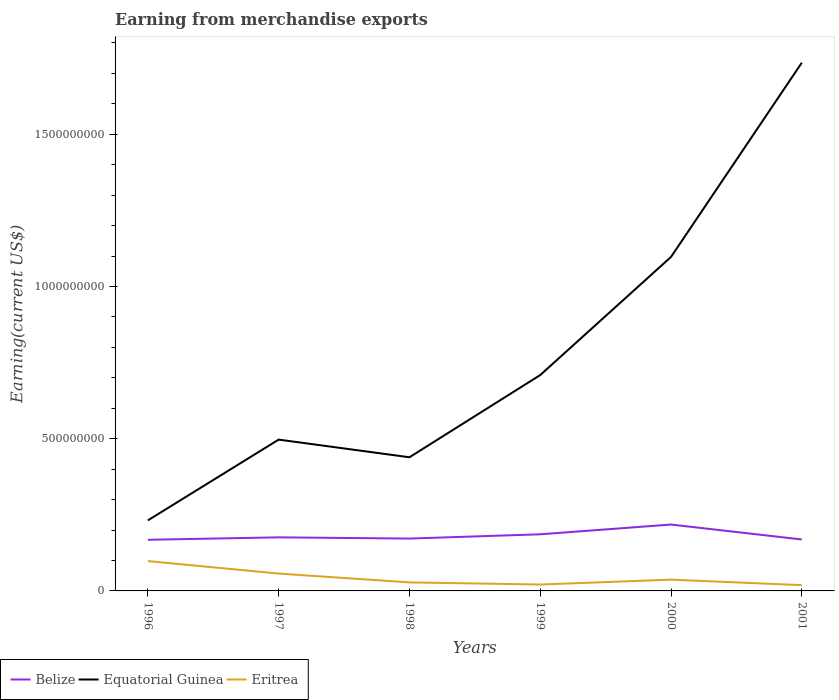How many different coloured lines are there?
Provide a short and direct response. 3. Is the number of lines equal to the number of legend labels?
Keep it short and to the point. Yes. Across all years, what is the maximum amount earned from merchandise exports in Eritrea?
Keep it short and to the point. 1.90e+07. In which year was the amount earned from merchandise exports in Equatorial Guinea maximum?
Offer a very short reply. 1996. What is the total amount earned from merchandise exports in Eritrea in the graph?
Offer a terse response. 7.70e+07. What is the difference between the highest and the lowest amount earned from merchandise exports in Equatorial Guinea?
Ensure brevity in your answer.  2. Is the amount earned from merchandise exports in Eritrea strictly greater than the amount earned from merchandise exports in Belize over the years?
Your answer should be compact. Yes. How many lines are there?
Your answer should be very brief. 3. Does the graph contain any zero values?
Make the answer very short. No. Does the graph contain grids?
Your answer should be very brief. No. Where does the legend appear in the graph?
Your response must be concise. Bottom left. How many legend labels are there?
Your answer should be compact. 3. What is the title of the graph?
Your answer should be very brief. Earning from merchandise exports. Does "Malawi" appear as one of the legend labels in the graph?
Provide a short and direct response. No. What is the label or title of the X-axis?
Give a very brief answer. Years. What is the label or title of the Y-axis?
Offer a very short reply. Earning(current US$). What is the Earning(current US$) of Belize in 1996?
Your answer should be very brief. 1.68e+08. What is the Earning(current US$) in Equatorial Guinea in 1996?
Ensure brevity in your answer.  2.32e+08. What is the Earning(current US$) of Eritrea in 1996?
Make the answer very short. 9.80e+07. What is the Earning(current US$) of Belize in 1997?
Your response must be concise. 1.76e+08. What is the Earning(current US$) of Equatorial Guinea in 1997?
Your response must be concise. 4.97e+08. What is the Earning(current US$) of Eritrea in 1997?
Give a very brief answer. 5.70e+07. What is the Earning(current US$) in Belize in 1998?
Your answer should be compact. 1.72e+08. What is the Earning(current US$) in Equatorial Guinea in 1998?
Offer a terse response. 4.39e+08. What is the Earning(current US$) of Eritrea in 1998?
Offer a very short reply. 2.80e+07. What is the Earning(current US$) in Belize in 1999?
Keep it short and to the point. 1.86e+08. What is the Earning(current US$) of Equatorial Guinea in 1999?
Give a very brief answer. 7.09e+08. What is the Earning(current US$) of Eritrea in 1999?
Offer a very short reply. 2.10e+07. What is the Earning(current US$) in Belize in 2000?
Provide a short and direct response. 2.18e+08. What is the Earning(current US$) in Equatorial Guinea in 2000?
Provide a succinct answer. 1.10e+09. What is the Earning(current US$) of Eritrea in 2000?
Make the answer very short. 3.70e+07. What is the Earning(current US$) of Belize in 2001?
Your response must be concise. 1.69e+08. What is the Earning(current US$) in Equatorial Guinea in 2001?
Offer a terse response. 1.74e+09. What is the Earning(current US$) of Eritrea in 2001?
Provide a short and direct response. 1.90e+07. Across all years, what is the maximum Earning(current US$) in Belize?
Your response must be concise. 2.18e+08. Across all years, what is the maximum Earning(current US$) in Equatorial Guinea?
Provide a short and direct response. 1.74e+09. Across all years, what is the maximum Earning(current US$) of Eritrea?
Your response must be concise. 9.80e+07. Across all years, what is the minimum Earning(current US$) of Belize?
Offer a terse response. 1.68e+08. Across all years, what is the minimum Earning(current US$) of Equatorial Guinea?
Give a very brief answer. 2.32e+08. Across all years, what is the minimum Earning(current US$) of Eritrea?
Make the answer very short. 1.90e+07. What is the total Earning(current US$) in Belize in the graph?
Your answer should be compact. 1.09e+09. What is the total Earning(current US$) in Equatorial Guinea in the graph?
Give a very brief answer. 4.71e+09. What is the total Earning(current US$) of Eritrea in the graph?
Provide a short and direct response. 2.60e+08. What is the difference between the Earning(current US$) in Belize in 1996 and that in 1997?
Your answer should be very brief. -8.00e+06. What is the difference between the Earning(current US$) of Equatorial Guinea in 1996 and that in 1997?
Make the answer very short. -2.65e+08. What is the difference between the Earning(current US$) of Eritrea in 1996 and that in 1997?
Provide a short and direct response. 4.10e+07. What is the difference between the Earning(current US$) of Belize in 1996 and that in 1998?
Ensure brevity in your answer.  -4.00e+06. What is the difference between the Earning(current US$) in Equatorial Guinea in 1996 and that in 1998?
Your response must be concise. -2.07e+08. What is the difference between the Earning(current US$) of Eritrea in 1996 and that in 1998?
Your response must be concise. 7.00e+07. What is the difference between the Earning(current US$) in Belize in 1996 and that in 1999?
Your response must be concise. -1.80e+07. What is the difference between the Earning(current US$) of Equatorial Guinea in 1996 and that in 1999?
Keep it short and to the point. -4.77e+08. What is the difference between the Earning(current US$) in Eritrea in 1996 and that in 1999?
Your answer should be compact. 7.70e+07. What is the difference between the Earning(current US$) in Belize in 1996 and that in 2000?
Offer a terse response. -5.00e+07. What is the difference between the Earning(current US$) in Equatorial Guinea in 1996 and that in 2000?
Keep it short and to the point. -8.65e+08. What is the difference between the Earning(current US$) in Eritrea in 1996 and that in 2000?
Ensure brevity in your answer.  6.10e+07. What is the difference between the Earning(current US$) in Belize in 1996 and that in 2001?
Your answer should be compact. -1.00e+06. What is the difference between the Earning(current US$) of Equatorial Guinea in 1996 and that in 2001?
Make the answer very short. -1.50e+09. What is the difference between the Earning(current US$) in Eritrea in 1996 and that in 2001?
Provide a succinct answer. 7.90e+07. What is the difference between the Earning(current US$) of Belize in 1997 and that in 1998?
Ensure brevity in your answer.  4.00e+06. What is the difference between the Earning(current US$) of Equatorial Guinea in 1997 and that in 1998?
Offer a very short reply. 5.80e+07. What is the difference between the Earning(current US$) in Eritrea in 1997 and that in 1998?
Keep it short and to the point. 2.90e+07. What is the difference between the Earning(current US$) in Belize in 1997 and that in 1999?
Give a very brief answer. -1.00e+07. What is the difference between the Earning(current US$) in Equatorial Guinea in 1997 and that in 1999?
Keep it short and to the point. -2.12e+08. What is the difference between the Earning(current US$) of Eritrea in 1997 and that in 1999?
Offer a terse response. 3.60e+07. What is the difference between the Earning(current US$) of Belize in 1997 and that in 2000?
Make the answer very short. -4.20e+07. What is the difference between the Earning(current US$) in Equatorial Guinea in 1997 and that in 2000?
Ensure brevity in your answer.  -6.00e+08. What is the difference between the Earning(current US$) in Eritrea in 1997 and that in 2000?
Ensure brevity in your answer.  2.00e+07. What is the difference between the Earning(current US$) in Equatorial Guinea in 1997 and that in 2001?
Keep it short and to the point. -1.24e+09. What is the difference between the Earning(current US$) of Eritrea in 1997 and that in 2001?
Your answer should be very brief. 3.80e+07. What is the difference between the Earning(current US$) in Belize in 1998 and that in 1999?
Offer a terse response. -1.40e+07. What is the difference between the Earning(current US$) of Equatorial Guinea in 1998 and that in 1999?
Provide a short and direct response. -2.70e+08. What is the difference between the Earning(current US$) of Belize in 1998 and that in 2000?
Provide a short and direct response. -4.60e+07. What is the difference between the Earning(current US$) of Equatorial Guinea in 1998 and that in 2000?
Provide a succinct answer. -6.58e+08. What is the difference between the Earning(current US$) of Eritrea in 1998 and that in 2000?
Provide a succinct answer. -9.00e+06. What is the difference between the Earning(current US$) in Equatorial Guinea in 1998 and that in 2001?
Your response must be concise. -1.30e+09. What is the difference between the Earning(current US$) of Eritrea in 1998 and that in 2001?
Your answer should be very brief. 9.00e+06. What is the difference between the Earning(current US$) in Belize in 1999 and that in 2000?
Provide a short and direct response. -3.20e+07. What is the difference between the Earning(current US$) in Equatorial Guinea in 1999 and that in 2000?
Provide a succinct answer. -3.88e+08. What is the difference between the Earning(current US$) in Eritrea in 1999 and that in 2000?
Your response must be concise. -1.60e+07. What is the difference between the Earning(current US$) in Belize in 1999 and that in 2001?
Your answer should be compact. 1.70e+07. What is the difference between the Earning(current US$) of Equatorial Guinea in 1999 and that in 2001?
Make the answer very short. -1.03e+09. What is the difference between the Earning(current US$) of Eritrea in 1999 and that in 2001?
Your answer should be compact. 2.00e+06. What is the difference between the Earning(current US$) in Belize in 2000 and that in 2001?
Offer a terse response. 4.90e+07. What is the difference between the Earning(current US$) of Equatorial Guinea in 2000 and that in 2001?
Your answer should be very brief. -6.38e+08. What is the difference between the Earning(current US$) in Eritrea in 2000 and that in 2001?
Offer a terse response. 1.80e+07. What is the difference between the Earning(current US$) in Belize in 1996 and the Earning(current US$) in Equatorial Guinea in 1997?
Make the answer very short. -3.29e+08. What is the difference between the Earning(current US$) of Belize in 1996 and the Earning(current US$) of Eritrea in 1997?
Offer a very short reply. 1.11e+08. What is the difference between the Earning(current US$) in Equatorial Guinea in 1996 and the Earning(current US$) in Eritrea in 1997?
Ensure brevity in your answer.  1.75e+08. What is the difference between the Earning(current US$) in Belize in 1996 and the Earning(current US$) in Equatorial Guinea in 1998?
Provide a succinct answer. -2.71e+08. What is the difference between the Earning(current US$) in Belize in 1996 and the Earning(current US$) in Eritrea in 1998?
Give a very brief answer. 1.40e+08. What is the difference between the Earning(current US$) in Equatorial Guinea in 1996 and the Earning(current US$) in Eritrea in 1998?
Ensure brevity in your answer.  2.04e+08. What is the difference between the Earning(current US$) in Belize in 1996 and the Earning(current US$) in Equatorial Guinea in 1999?
Give a very brief answer. -5.41e+08. What is the difference between the Earning(current US$) of Belize in 1996 and the Earning(current US$) of Eritrea in 1999?
Ensure brevity in your answer.  1.47e+08. What is the difference between the Earning(current US$) in Equatorial Guinea in 1996 and the Earning(current US$) in Eritrea in 1999?
Provide a succinct answer. 2.11e+08. What is the difference between the Earning(current US$) in Belize in 1996 and the Earning(current US$) in Equatorial Guinea in 2000?
Offer a very short reply. -9.29e+08. What is the difference between the Earning(current US$) of Belize in 1996 and the Earning(current US$) of Eritrea in 2000?
Provide a succinct answer. 1.31e+08. What is the difference between the Earning(current US$) of Equatorial Guinea in 1996 and the Earning(current US$) of Eritrea in 2000?
Provide a succinct answer. 1.95e+08. What is the difference between the Earning(current US$) in Belize in 1996 and the Earning(current US$) in Equatorial Guinea in 2001?
Your answer should be compact. -1.57e+09. What is the difference between the Earning(current US$) in Belize in 1996 and the Earning(current US$) in Eritrea in 2001?
Your response must be concise. 1.49e+08. What is the difference between the Earning(current US$) of Equatorial Guinea in 1996 and the Earning(current US$) of Eritrea in 2001?
Ensure brevity in your answer.  2.13e+08. What is the difference between the Earning(current US$) in Belize in 1997 and the Earning(current US$) in Equatorial Guinea in 1998?
Your answer should be compact. -2.63e+08. What is the difference between the Earning(current US$) in Belize in 1997 and the Earning(current US$) in Eritrea in 1998?
Give a very brief answer. 1.48e+08. What is the difference between the Earning(current US$) of Equatorial Guinea in 1997 and the Earning(current US$) of Eritrea in 1998?
Offer a terse response. 4.69e+08. What is the difference between the Earning(current US$) in Belize in 1997 and the Earning(current US$) in Equatorial Guinea in 1999?
Make the answer very short. -5.33e+08. What is the difference between the Earning(current US$) of Belize in 1997 and the Earning(current US$) of Eritrea in 1999?
Give a very brief answer. 1.55e+08. What is the difference between the Earning(current US$) of Equatorial Guinea in 1997 and the Earning(current US$) of Eritrea in 1999?
Your answer should be compact. 4.76e+08. What is the difference between the Earning(current US$) in Belize in 1997 and the Earning(current US$) in Equatorial Guinea in 2000?
Make the answer very short. -9.21e+08. What is the difference between the Earning(current US$) in Belize in 1997 and the Earning(current US$) in Eritrea in 2000?
Make the answer very short. 1.39e+08. What is the difference between the Earning(current US$) in Equatorial Guinea in 1997 and the Earning(current US$) in Eritrea in 2000?
Keep it short and to the point. 4.60e+08. What is the difference between the Earning(current US$) of Belize in 1997 and the Earning(current US$) of Equatorial Guinea in 2001?
Provide a short and direct response. -1.56e+09. What is the difference between the Earning(current US$) in Belize in 1997 and the Earning(current US$) in Eritrea in 2001?
Your response must be concise. 1.57e+08. What is the difference between the Earning(current US$) in Equatorial Guinea in 1997 and the Earning(current US$) in Eritrea in 2001?
Give a very brief answer. 4.78e+08. What is the difference between the Earning(current US$) in Belize in 1998 and the Earning(current US$) in Equatorial Guinea in 1999?
Offer a terse response. -5.37e+08. What is the difference between the Earning(current US$) in Belize in 1998 and the Earning(current US$) in Eritrea in 1999?
Ensure brevity in your answer.  1.51e+08. What is the difference between the Earning(current US$) in Equatorial Guinea in 1998 and the Earning(current US$) in Eritrea in 1999?
Provide a short and direct response. 4.18e+08. What is the difference between the Earning(current US$) of Belize in 1998 and the Earning(current US$) of Equatorial Guinea in 2000?
Ensure brevity in your answer.  -9.25e+08. What is the difference between the Earning(current US$) in Belize in 1998 and the Earning(current US$) in Eritrea in 2000?
Give a very brief answer. 1.35e+08. What is the difference between the Earning(current US$) of Equatorial Guinea in 1998 and the Earning(current US$) of Eritrea in 2000?
Ensure brevity in your answer.  4.02e+08. What is the difference between the Earning(current US$) of Belize in 1998 and the Earning(current US$) of Equatorial Guinea in 2001?
Ensure brevity in your answer.  -1.56e+09. What is the difference between the Earning(current US$) of Belize in 1998 and the Earning(current US$) of Eritrea in 2001?
Your answer should be very brief. 1.53e+08. What is the difference between the Earning(current US$) of Equatorial Guinea in 1998 and the Earning(current US$) of Eritrea in 2001?
Your answer should be very brief. 4.20e+08. What is the difference between the Earning(current US$) in Belize in 1999 and the Earning(current US$) in Equatorial Guinea in 2000?
Your answer should be very brief. -9.11e+08. What is the difference between the Earning(current US$) of Belize in 1999 and the Earning(current US$) of Eritrea in 2000?
Make the answer very short. 1.49e+08. What is the difference between the Earning(current US$) of Equatorial Guinea in 1999 and the Earning(current US$) of Eritrea in 2000?
Keep it short and to the point. 6.72e+08. What is the difference between the Earning(current US$) of Belize in 1999 and the Earning(current US$) of Equatorial Guinea in 2001?
Your answer should be very brief. -1.55e+09. What is the difference between the Earning(current US$) in Belize in 1999 and the Earning(current US$) in Eritrea in 2001?
Offer a terse response. 1.67e+08. What is the difference between the Earning(current US$) in Equatorial Guinea in 1999 and the Earning(current US$) in Eritrea in 2001?
Provide a succinct answer. 6.90e+08. What is the difference between the Earning(current US$) in Belize in 2000 and the Earning(current US$) in Equatorial Guinea in 2001?
Ensure brevity in your answer.  -1.52e+09. What is the difference between the Earning(current US$) of Belize in 2000 and the Earning(current US$) of Eritrea in 2001?
Your answer should be very brief. 1.99e+08. What is the difference between the Earning(current US$) of Equatorial Guinea in 2000 and the Earning(current US$) of Eritrea in 2001?
Make the answer very short. 1.08e+09. What is the average Earning(current US$) in Belize per year?
Keep it short and to the point. 1.82e+08. What is the average Earning(current US$) in Equatorial Guinea per year?
Make the answer very short. 7.85e+08. What is the average Earning(current US$) in Eritrea per year?
Keep it short and to the point. 4.33e+07. In the year 1996, what is the difference between the Earning(current US$) in Belize and Earning(current US$) in Equatorial Guinea?
Your answer should be compact. -6.38e+07. In the year 1996, what is the difference between the Earning(current US$) in Belize and Earning(current US$) in Eritrea?
Make the answer very short. 7.00e+07. In the year 1996, what is the difference between the Earning(current US$) of Equatorial Guinea and Earning(current US$) of Eritrea?
Your answer should be very brief. 1.34e+08. In the year 1997, what is the difference between the Earning(current US$) of Belize and Earning(current US$) of Equatorial Guinea?
Your response must be concise. -3.21e+08. In the year 1997, what is the difference between the Earning(current US$) of Belize and Earning(current US$) of Eritrea?
Offer a very short reply. 1.19e+08. In the year 1997, what is the difference between the Earning(current US$) of Equatorial Guinea and Earning(current US$) of Eritrea?
Your answer should be very brief. 4.40e+08. In the year 1998, what is the difference between the Earning(current US$) in Belize and Earning(current US$) in Equatorial Guinea?
Keep it short and to the point. -2.67e+08. In the year 1998, what is the difference between the Earning(current US$) of Belize and Earning(current US$) of Eritrea?
Your answer should be very brief. 1.44e+08. In the year 1998, what is the difference between the Earning(current US$) of Equatorial Guinea and Earning(current US$) of Eritrea?
Your response must be concise. 4.11e+08. In the year 1999, what is the difference between the Earning(current US$) in Belize and Earning(current US$) in Equatorial Guinea?
Make the answer very short. -5.23e+08. In the year 1999, what is the difference between the Earning(current US$) of Belize and Earning(current US$) of Eritrea?
Provide a succinct answer. 1.65e+08. In the year 1999, what is the difference between the Earning(current US$) in Equatorial Guinea and Earning(current US$) in Eritrea?
Keep it short and to the point. 6.88e+08. In the year 2000, what is the difference between the Earning(current US$) in Belize and Earning(current US$) in Equatorial Guinea?
Offer a very short reply. -8.79e+08. In the year 2000, what is the difference between the Earning(current US$) of Belize and Earning(current US$) of Eritrea?
Your answer should be compact. 1.81e+08. In the year 2000, what is the difference between the Earning(current US$) of Equatorial Guinea and Earning(current US$) of Eritrea?
Offer a very short reply. 1.06e+09. In the year 2001, what is the difference between the Earning(current US$) of Belize and Earning(current US$) of Equatorial Guinea?
Offer a very short reply. -1.57e+09. In the year 2001, what is the difference between the Earning(current US$) in Belize and Earning(current US$) in Eritrea?
Offer a very short reply. 1.50e+08. In the year 2001, what is the difference between the Earning(current US$) of Equatorial Guinea and Earning(current US$) of Eritrea?
Offer a terse response. 1.72e+09. What is the ratio of the Earning(current US$) in Belize in 1996 to that in 1997?
Keep it short and to the point. 0.95. What is the ratio of the Earning(current US$) in Equatorial Guinea in 1996 to that in 1997?
Offer a terse response. 0.47. What is the ratio of the Earning(current US$) in Eritrea in 1996 to that in 1997?
Offer a terse response. 1.72. What is the ratio of the Earning(current US$) in Belize in 1996 to that in 1998?
Offer a very short reply. 0.98. What is the ratio of the Earning(current US$) of Equatorial Guinea in 1996 to that in 1998?
Make the answer very short. 0.53. What is the ratio of the Earning(current US$) of Eritrea in 1996 to that in 1998?
Provide a short and direct response. 3.5. What is the ratio of the Earning(current US$) in Belize in 1996 to that in 1999?
Provide a short and direct response. 0.9. What is the ratio of the Earning(current US$) of Equatorial Guinea in 1996 to that in 1999?
Ensure brevity in your answer.  0.33. What is the ratio of the Earning(current US$) in Eritrea in 1996 to that in 1999?
Provide a short and direct response. 4.67. What is the ratio of the Earning(current US$) in Belize in 1996 to that in 2000?
Ensure brevity in your answer.  0.77. What is the ratio of the Earning(current US$) in Equatorial Guinea in 1996 to that in 2000?
Provide a succinct answer. 0.21. What is the ratio of the Earning(current US$) of Eritrea in 1996 to that in 2000?
Provide a succinct answer. 2.65. What is the ratio of the Earning(current US$) in Equatorial Guinea in 1996 to that in 2001?
Ensure brevity in your answer.  0.13. What is the ratio of the Earning(current US$) of Eritrea in 1996 to that in 2001?
Keep it short and to the point. 5.16. What is the ratio of the Earning(current US$) in Belize in 1997 to that in 1998?
Keep it short and to the point. 1.02. What is the ratio of the Earning(current US$) of Equatorial Guinea in 1997 to that in 1998?
Provide a succinct answer. 1.13. What is the ratio of the Earning(current US$) of Eritrea in 1997 to that in 1998?
Give a very brief answer. 2.04. What is the ratio of the Earning(current US$) in Belize in 1997 to that in 1999?
Give a very brief answer. 0.95. What is the ratio of the Earning(current US$) of Equatorial Guinea in 1997 to that in 1999?
Your answer should be compact. 0.7. What is the ratio of the Earning(current US$) in Eritrea in 1997 to that in 1999?
Your answer should be compact. 2.71. What is the ratio of the Earning(current US$) of Belize in 1997 to that in 2000?
Your answer should be compact. 0.81. What is the ratio of the Earning(current US$) in Equatorial Guinea in 1997 to that in 2000?
Offer a terse response. 0.45. What is the ratio of the Earning(current US$) in Eritrea in 1997 to that in 2000?
Keep it short and to the point. 1.54. What is the ratio of the Earning(current US$) of Belize in 1997 to that in 2001?
Keep it short and to the point. 1.04. What is the ratio of the Earning(current US$) of Equatorial Guinea in 1997 to that in 2001?
Keep it short and to the point. 0.29. What is the ratio of the Earning(current US$) in Eritrea in 1997 to that in 2001?
Offer a terse response. 3. What is the ratio of the Earning(current US$) of Belize in 1998 to that in 1999?
Your response must be concise. 0.92. What is the ratio of the Earning(current US$) of Equatorial Guinea in 1998 to that in 1999?
Provide a short and direct response. 0.62. What is the ratio of the Earning(current US$) in Eritrea in 1998 to that in 1999?
Offer a terse response. 1.33. What is the ratio of the Earning(current US$) of Belize in 1998 to that in 2000?
Your response must be concise. 0.79. What is the ratio of the Earning(current US$) in Equatorial Guinea in 1998 to that in 2000?
Keep it short and to the point. 0.4. What is the ratio of the Earning(current US$) of Eritrea in 1998 to that in 2000?
Offer a very short reply. 0.76. What is the ratio of the Earning(current US$) of Belize in 1998 to that in 2001?
Offer a terse response. 1.02. What is the ratio of the Earning(current US$) in Equatorial Guinea in 1998 to that in 2001?
Provide a succinct answer. 0.25. What is the ratio of the Earning(current US$) in Eritrea in 1998 to that in 2001?
Make the answer very short. 1.47. What is the ratio of the Earning(current US$) of Belize in 1999 to that in 2000?
Your answer should be very brief. 0.85. What is the ratio of the Earning(current US$) in Equatorial Guinea in 1999 to that in 2000?
Offer a very short reply. 0.65. What is the ratio of the Earning(current US$) of Eritrea in 1999 to that in 2000?
Offer a very short reply. 0.57. What is the ratio of the Earning(current US$) in Belize in 1999 to that in 2001?
Offer a very short reply. 1.1. What is the ratio of the Earning(current US$) of Equatorial Guinea in 1999 to that in 2001?
Offer a terse response. 0.41. What is the ratio of the Earning(current US$) of Eritrea in 1999 to that in 2001?
Keep it short and to the point. 1.11. What is the ratio of the Earning(current US$) of Belize in 2000 to that in 2001?
Offer a terse response. 1.29. What is the ratio of the Earning(current US$) in Equatorial Guinea in 2000 to that in 2001?
Offer a very short reply. 0.63. What is the ratio of the Earning(current US$) in Eritrea in 2000 to that in 2001?
Give a very brief answer. 1.95. What is the difference between the highest and the second highest Earning(current US$) of Belize?
Provide a succinct answer. 3.20e+07. What is the difference between the highest and the second highest Earning(current US$) of Equatorial Guinea?
Provide a succinct answer. 6.38e+08. What is the difference between the highest and the second highest Earning(current US$) in Eritrea?
Offer a terse response. 4.10e+07. What is the difference between the highest and the lowest Earning(current US$) of Equatorial Guinea?
Ensure brevity in your answer.  1.50e+09. What is the difference between the highest and the lowest Earning(current US$) of Eritrea?
Your answer should be compact. 7.90e+07. 